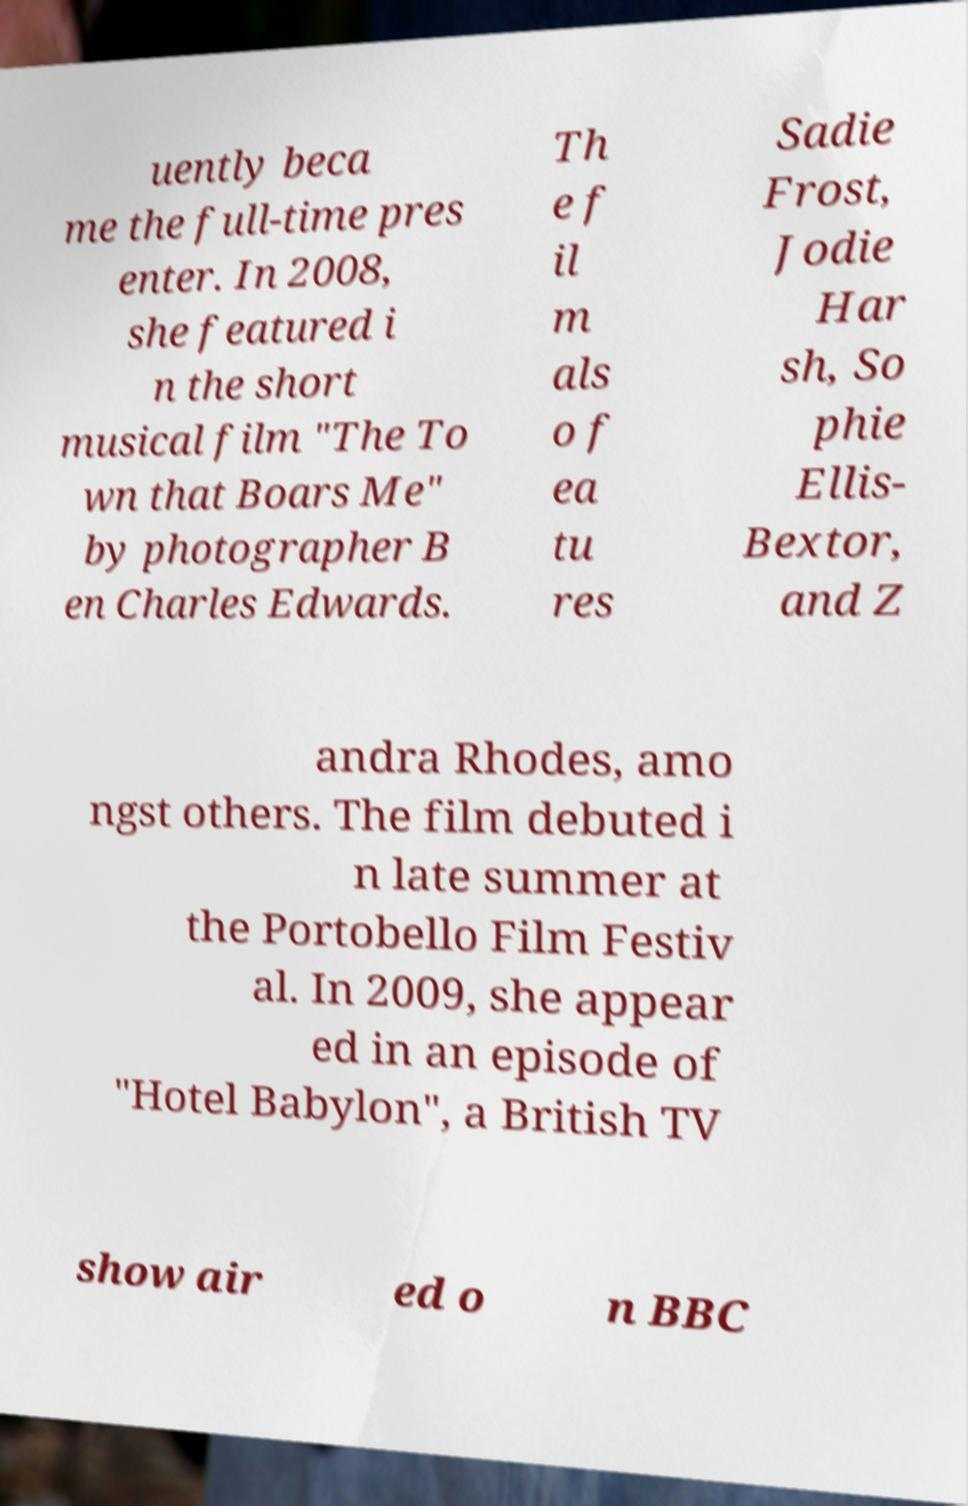Please read and relay the text visible in this image. What does it say? uently beca me the full-time pres enter. In 2008, she featured i n the short musical film "The To wn that Boars Me" by photographer B en Charles Edwards. Th e f il m als o f ea tu res Sadie Frost, Jodie Har sh, So phie Ellis- Bextor, and Z andra Rhodes, amo ngst others. The film debuted i n late summer at the Portobello Film Festiv al. In 2009, she appear ed in an episode of "Hotel Babylon", a British TV show air ed o n BBC 